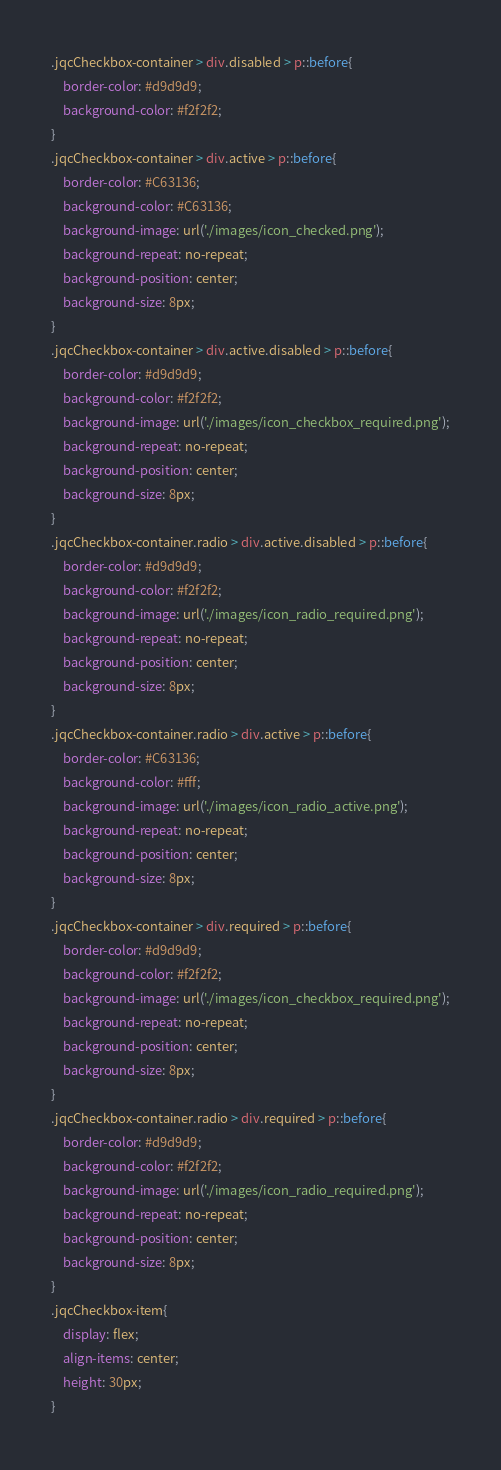<code> <loc_0><loc_0><loc_500><loc_500><_CSS_>.jqcCheckbox-container > div.disabled > p::before{
    border-color: #d9d9d9;
    background-color: #f2f2f2;
}
.jqcCheckbox-container > div.active > p::before{
    border-color: #C63136;
    background-color: #C63136;
    background-image: url('./images/icon_checked.png');
    background-repeat: no-repeat;
    background-position: center;
    background-size: 8px;
}
.jqcCheckbox-container > div.active.disabled > p::before{
    border-color: #d9d9d9;
    background-color: #f2f2f2;
    background-image: url('./images/icon_checkbox_required.png');
    background-repeat: no-repeat;
    background-position: center;
    background-size: 8px;
}
.jqcCheckbox-container.radio > div.active.disabled > p::before{
    border-color: #d9d9d9;
    background-color: #f2f2f2;
    background-image: url('./images/icon_radio_required.png');
    background-repeat: no-repeat;
    background-position: center;
    background-size: 8px;
}
.jqcCheckbox-container.radio > div.active > p::before{
    border-color: #C63136;
    background-color: #fff;
    background-image: url('./images/icon_radio_active.png');
    background-repeat: no-repeat;
    background-position: center;
    background-size: 8px;
}
.jqcCheckbox-container > div.required > p::before{
    border-color: #d9d9d9;
    background-color: #f2f2f2;
    background-image: url('./images/icon_checkbox_required.png');
    background-repeat: no-repeat;
    background-position: center;
    background-size: 8px;
}
.jqcCheckbox-container.radio > div.required > p::before{
    border-color: #d9d9d9;
    background-color: #f2f2f2;
    background-image: url('./images/icon_radio_required.png');
    background-repeat: no-repeat;
    background-position: center;
    background-size: 8px;
}
.jqcCheckbox-item{
    display: flex;
    align-items: center;
    height: 30px;
}</code> 